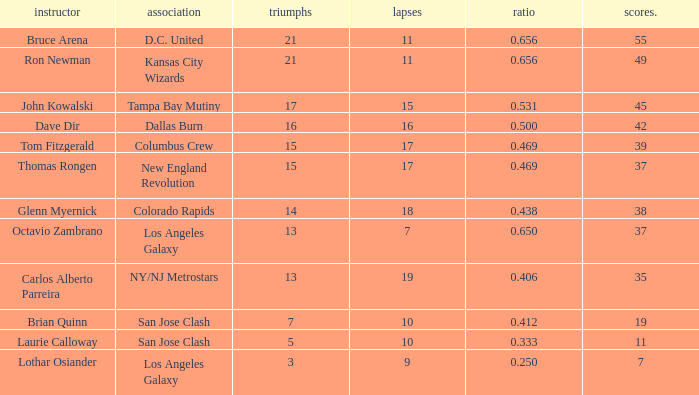What is the sum of points when Bruce Arena has 21 wins? 55.0. 